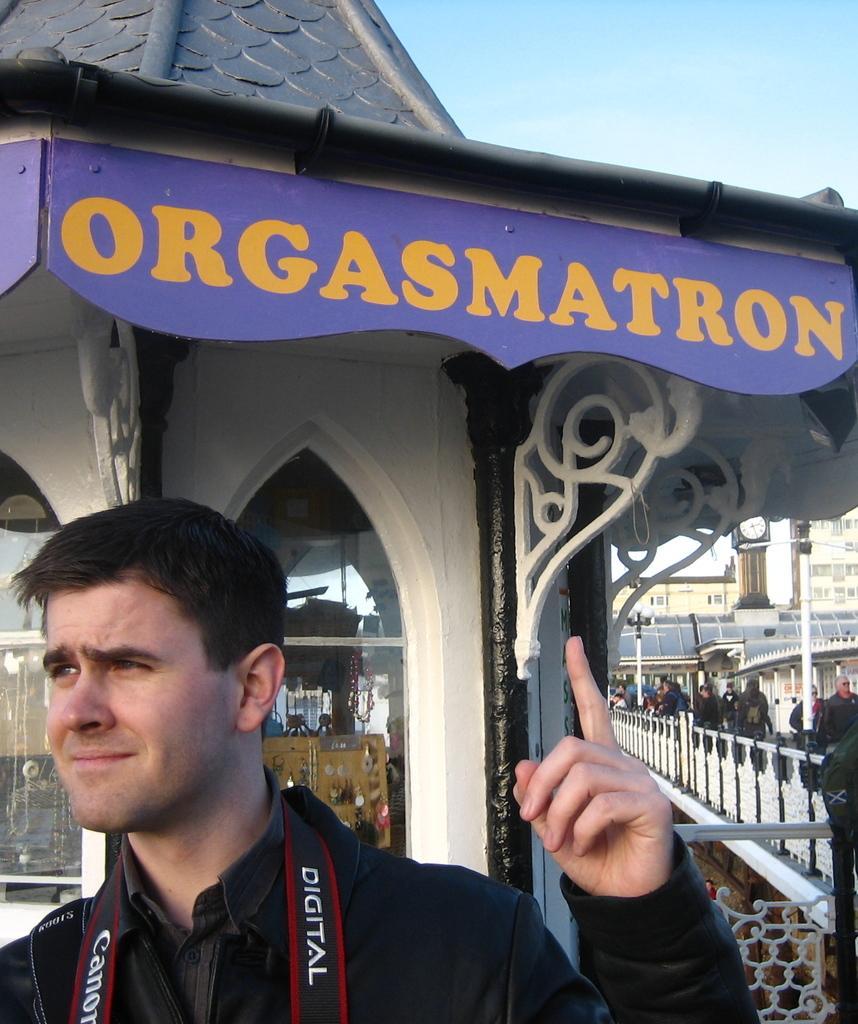In one or two sentences, can you explain what this image depicts? In the image we can see a man wearing clothes, this is a building, fence, window and a sky. We can see there are even other people. 